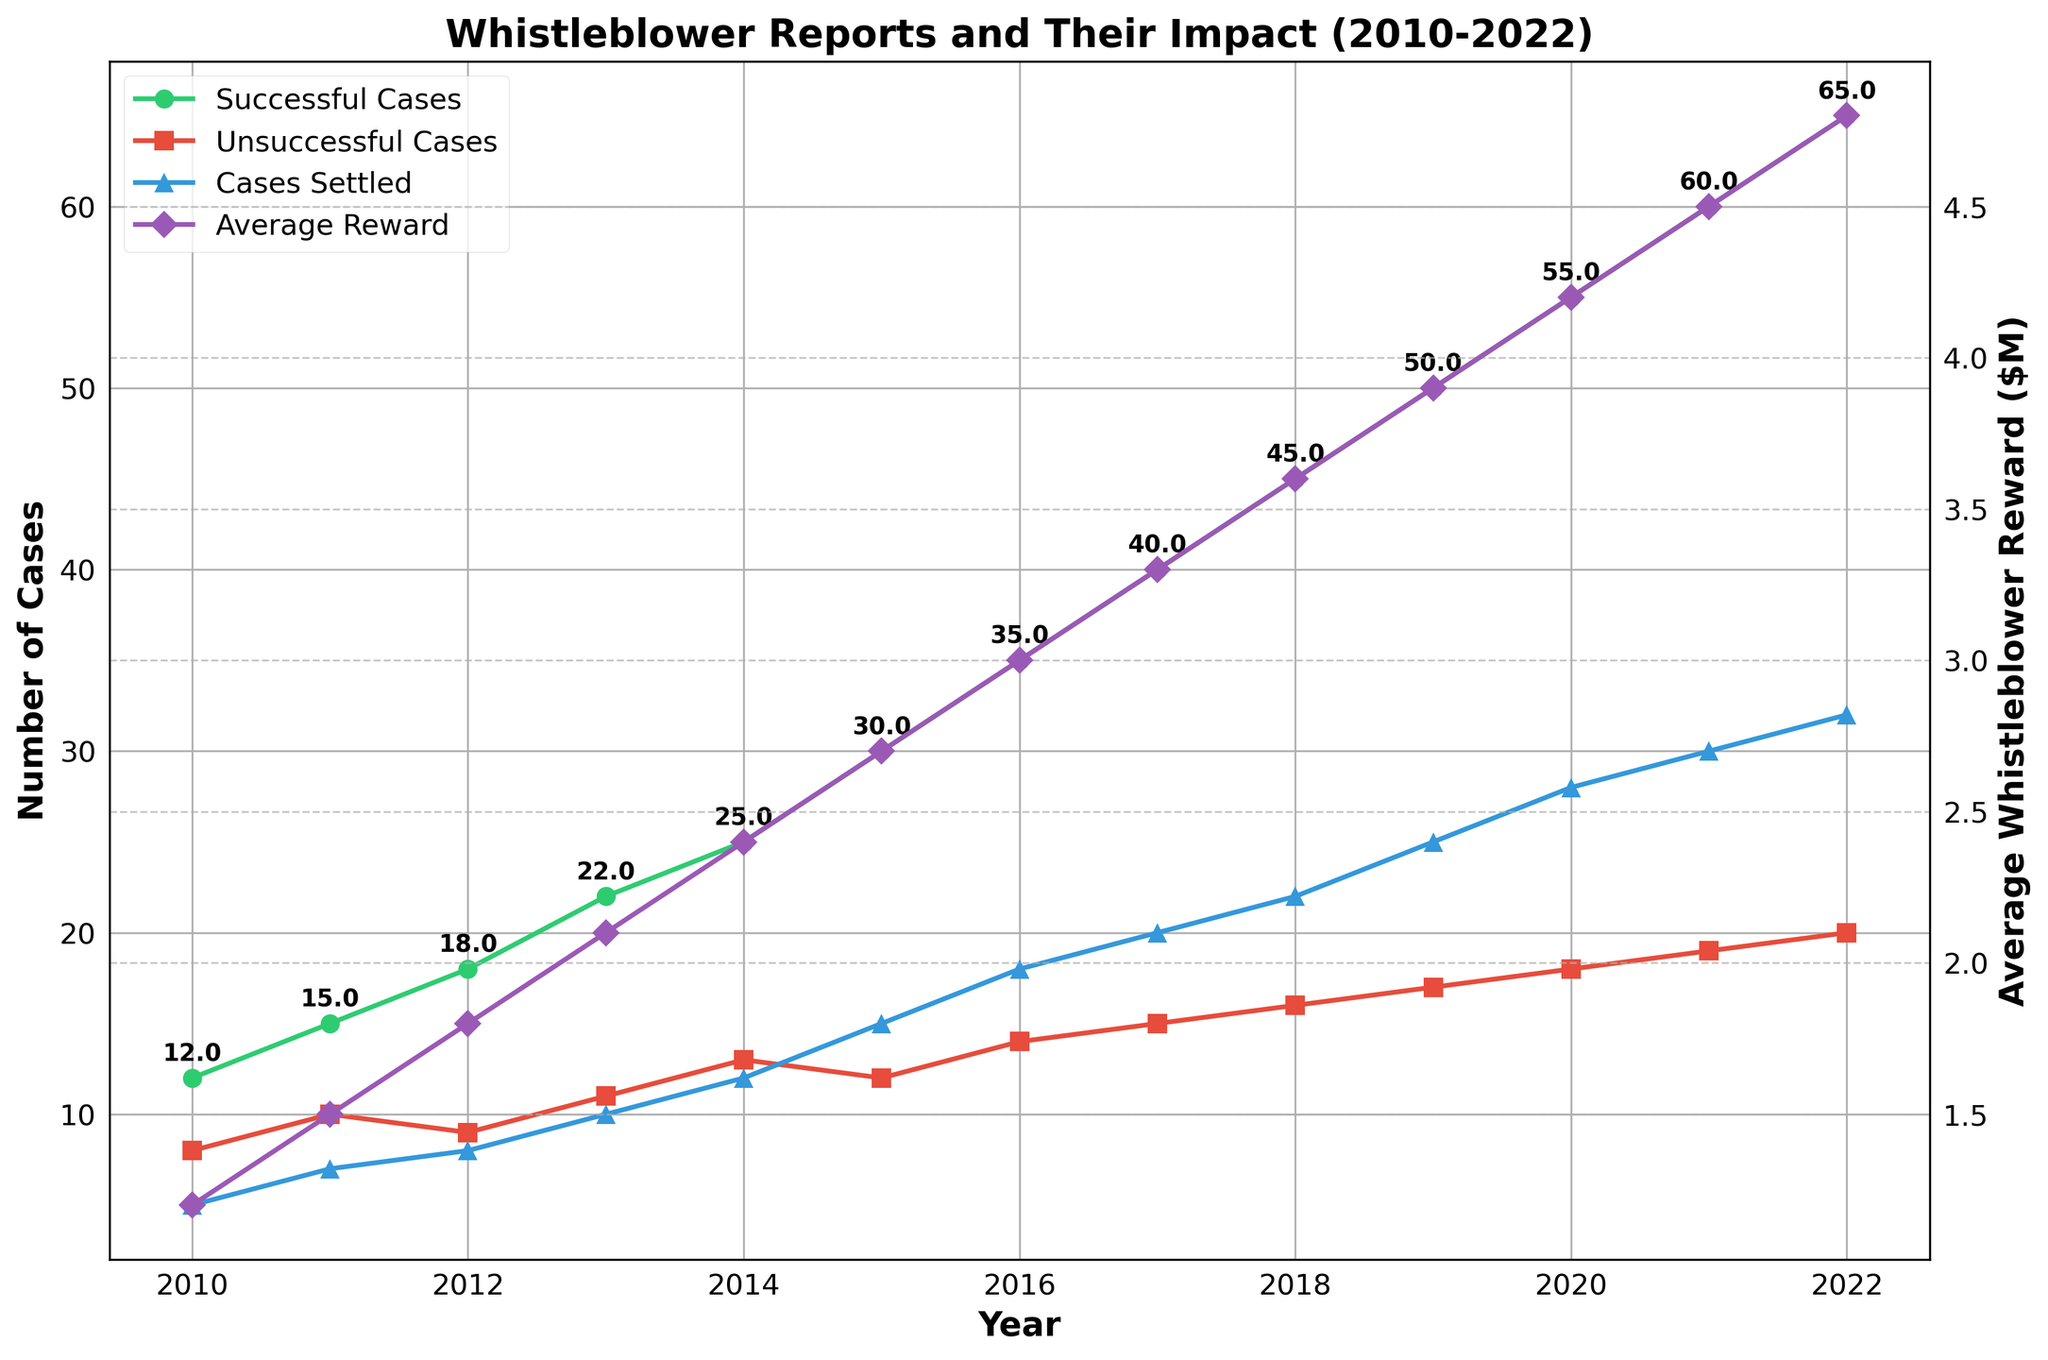What year saw the highest number of successful cases? Identify the peak point on the line representing 'Successful Cases' (the green line) and see which year it corresponds to.
Answer: 2022 How much has the average whistleblower reward increased from 2010 to 2022? Subtract the average reward in 2010 from the average reward in 2022 (4.8 - 1.2).
Answer: 3.6 million In which year did the number of cases settled surpass 20? Locate the year on the line representing 'Cases Settled' (the blue line) where it first exceeds 20 cases.
Answer: 2018 Which year had the closest number of unsuccessful cases and cases settled? Compare the differences between the 'Unsuccessful Cases' and 'Cases Settled' lines year by year to find the smallest gap.
Answer: 2015 What was the total number of cases (sum of successful, unsuccessful, and settled) in 2015? Add the number of successful, unsuccessful, and settled cases for 2015 (30 + 12 + 15).
Answer: 57 Compare the growth rate from 2010 to 2022 for successful cases and cases settled. Which grew faster? Calculate the growth of both 'Successful Cases' (from 12 to 65) and 'Cases Settled' (from 5 to 32) and compare them. Growth for successful cases is (65 - 12) = 53, and for cases settled is (32 - 5) = 27.
Answer: Successful Cases In which year was the number of unsuccessful cases equal to half the number of successful cases? Divide the number of successful cases by 2 for each year and compare it with the number of unsuccessful cases to see which year they match.
Answer: 2010 What is the color used to represent the average whistleblower reward line on the chart? Identify the color of the line that represents 'Average Reward' on the chat, indicated by the legend.
Answer: Purple 